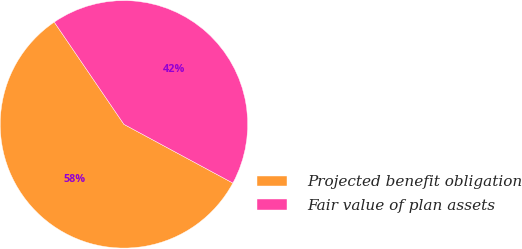Convert chart. <chart><loc_0><loc_0><loc_500><loc_500><pie_chart><fcel>Projected benefit obligation<fcel>Fair value of plan assets<nl><fcel>57.61%<fcel>42.39%<nl></chart> 